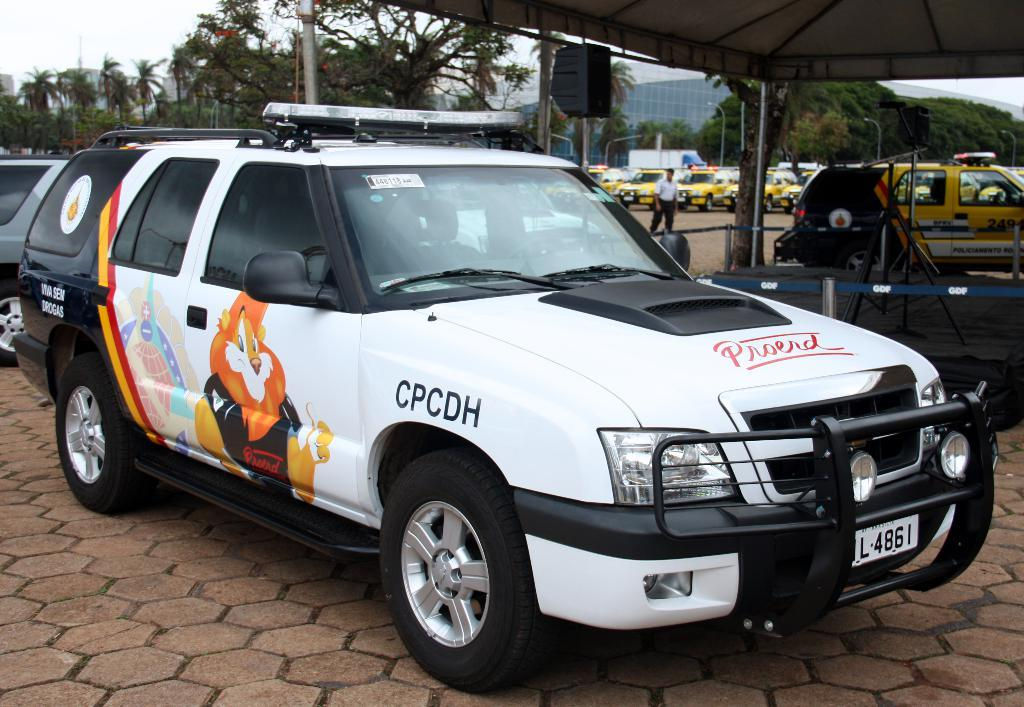What can be seen on the road in the image? There are cars parked on the road in the image. What structure is located at the center of the image? There is a shed at the center of the image. What type of vegetation is visible in the background of the image? There are trees in the background of the image. What else can be seen in the background of the image? There are buildings and the sky visible in the background of the image. What type of organization is protesting in the image? There is no protest or organization present in the image; it features cars parked on the road, a shed, trees, buildings, and the sky. What group of people can be seen gathering around the shed in the image? There is no group of people gathered around the shed in the image; it only shows the shed and the surrounding environment. 